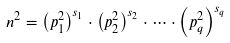Convert formula to latex. <formula><loc_0><loc_0><loc_500><loc_500>n ^ { 2 } = \left ( p _ { 1 } ^ { 2 } \right ) ^ { s _ { 1 } } \cdot \left ( p _ { 2 } ^ { 2 } \right ) ^ { s _ { 2 } } \cdot \dots \cdot \left ( p _ { q } ^ { 2 } \right ) ^ { s _ { q } }</formula> 